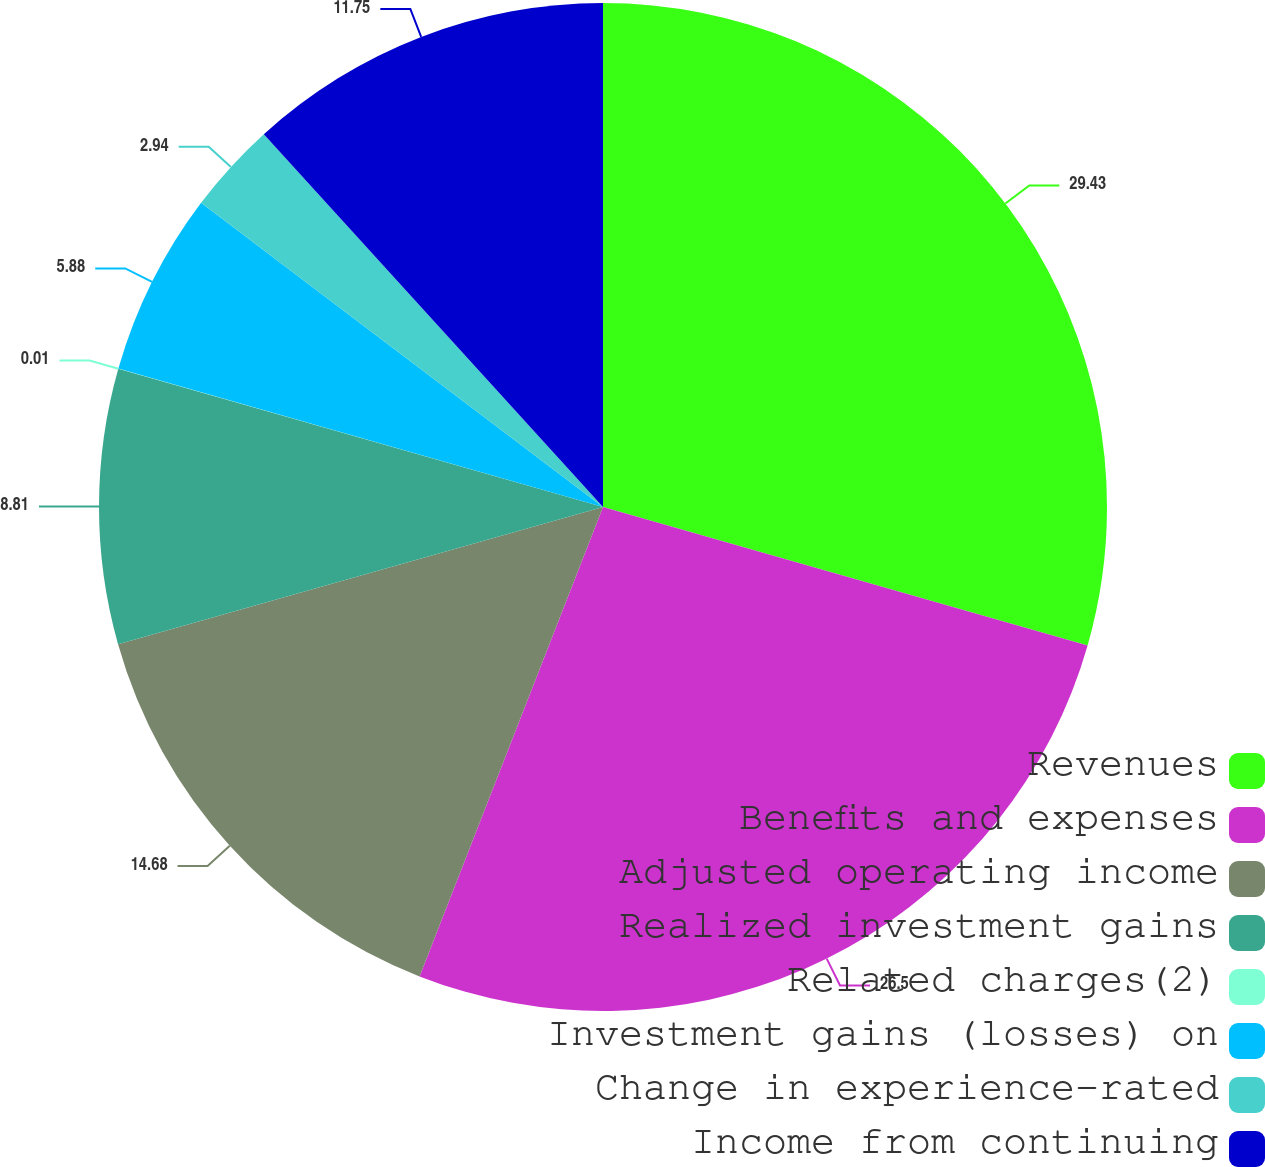Convert chart to OTSL. <chart><loc_0><loc_0><loc_500><loc_500><pie_chart><fcel>Revenues<fcel>Benefits and expenses<fcel>Adjusted operating income<fcel>Realized investment gains<fcel>Related charges(2)<fcel>Investment gains (losses) on<fcel>Change in experience-rated<fcel>Income from continuing<nl><fcel>29.43%<fcel>26.5%<fcel>14.68%<fcel>8.81%<fcel>0.01%<fcel>5.88%<fcel>2.94%<fcel>11.75%<nl></chart> 